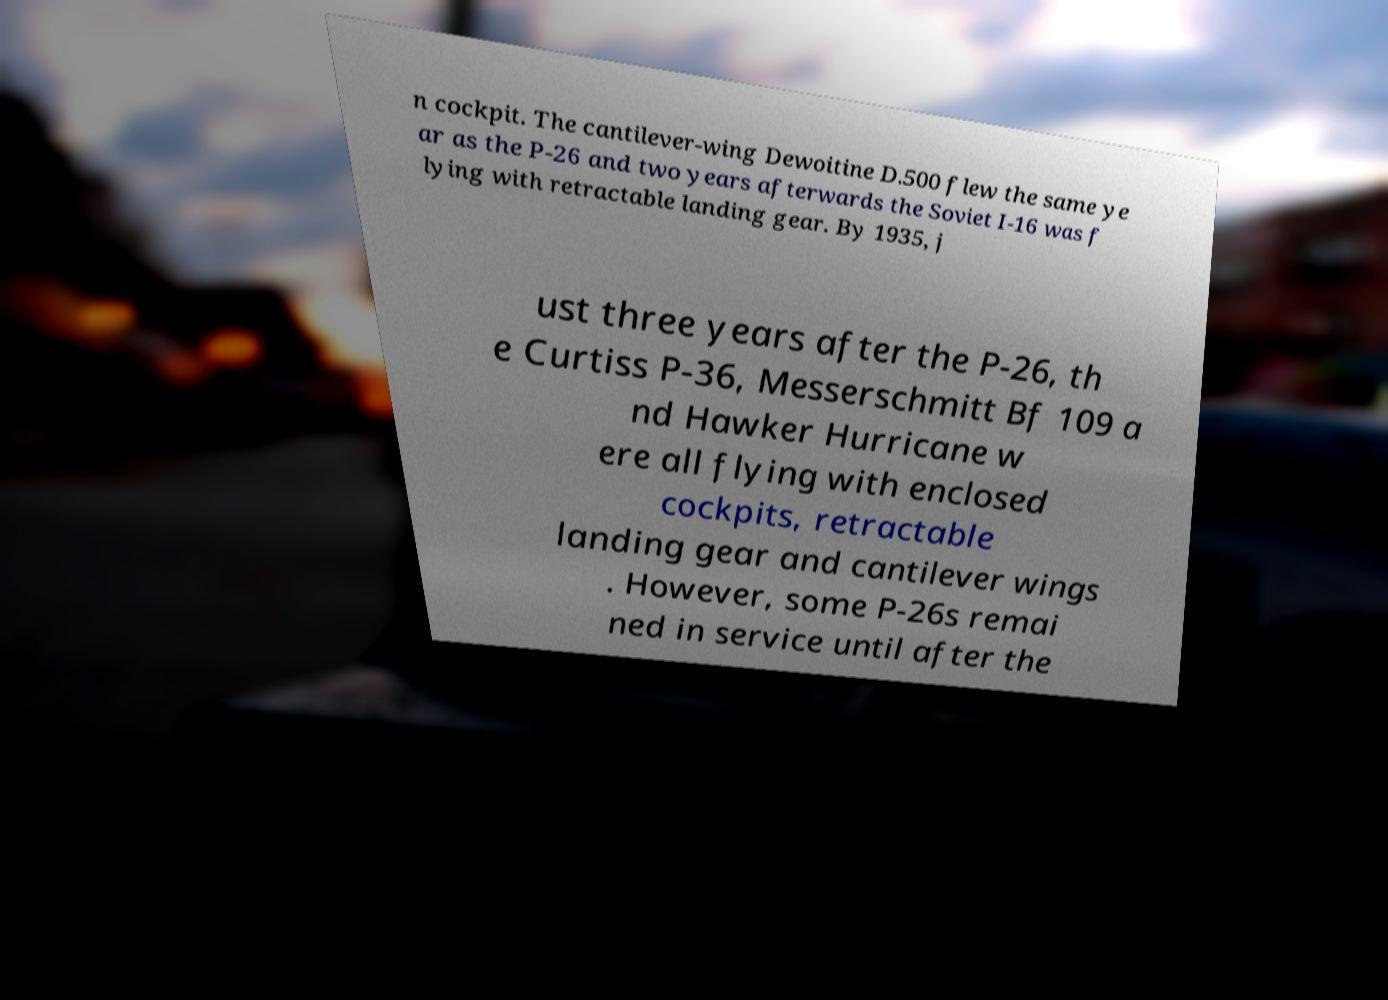For documentation purposes, I need the text within this image transcribed. Could you provide that? n cockpit. The cantilever-wing Dewoitine D.500 flew the same ye ar as the P-26 and two years afterwards the Soviet I-16 was f lying with retractable landing gear. By 1935, j ust three years after the P-26, th e Curtiss P-36, Messerschmitt Bf 109 a nd Hawker Hurricane w ere all flying with enclosed cockpits, retractable landing gear and cantilever wings . However, some P-26s remai ned in service until after the 